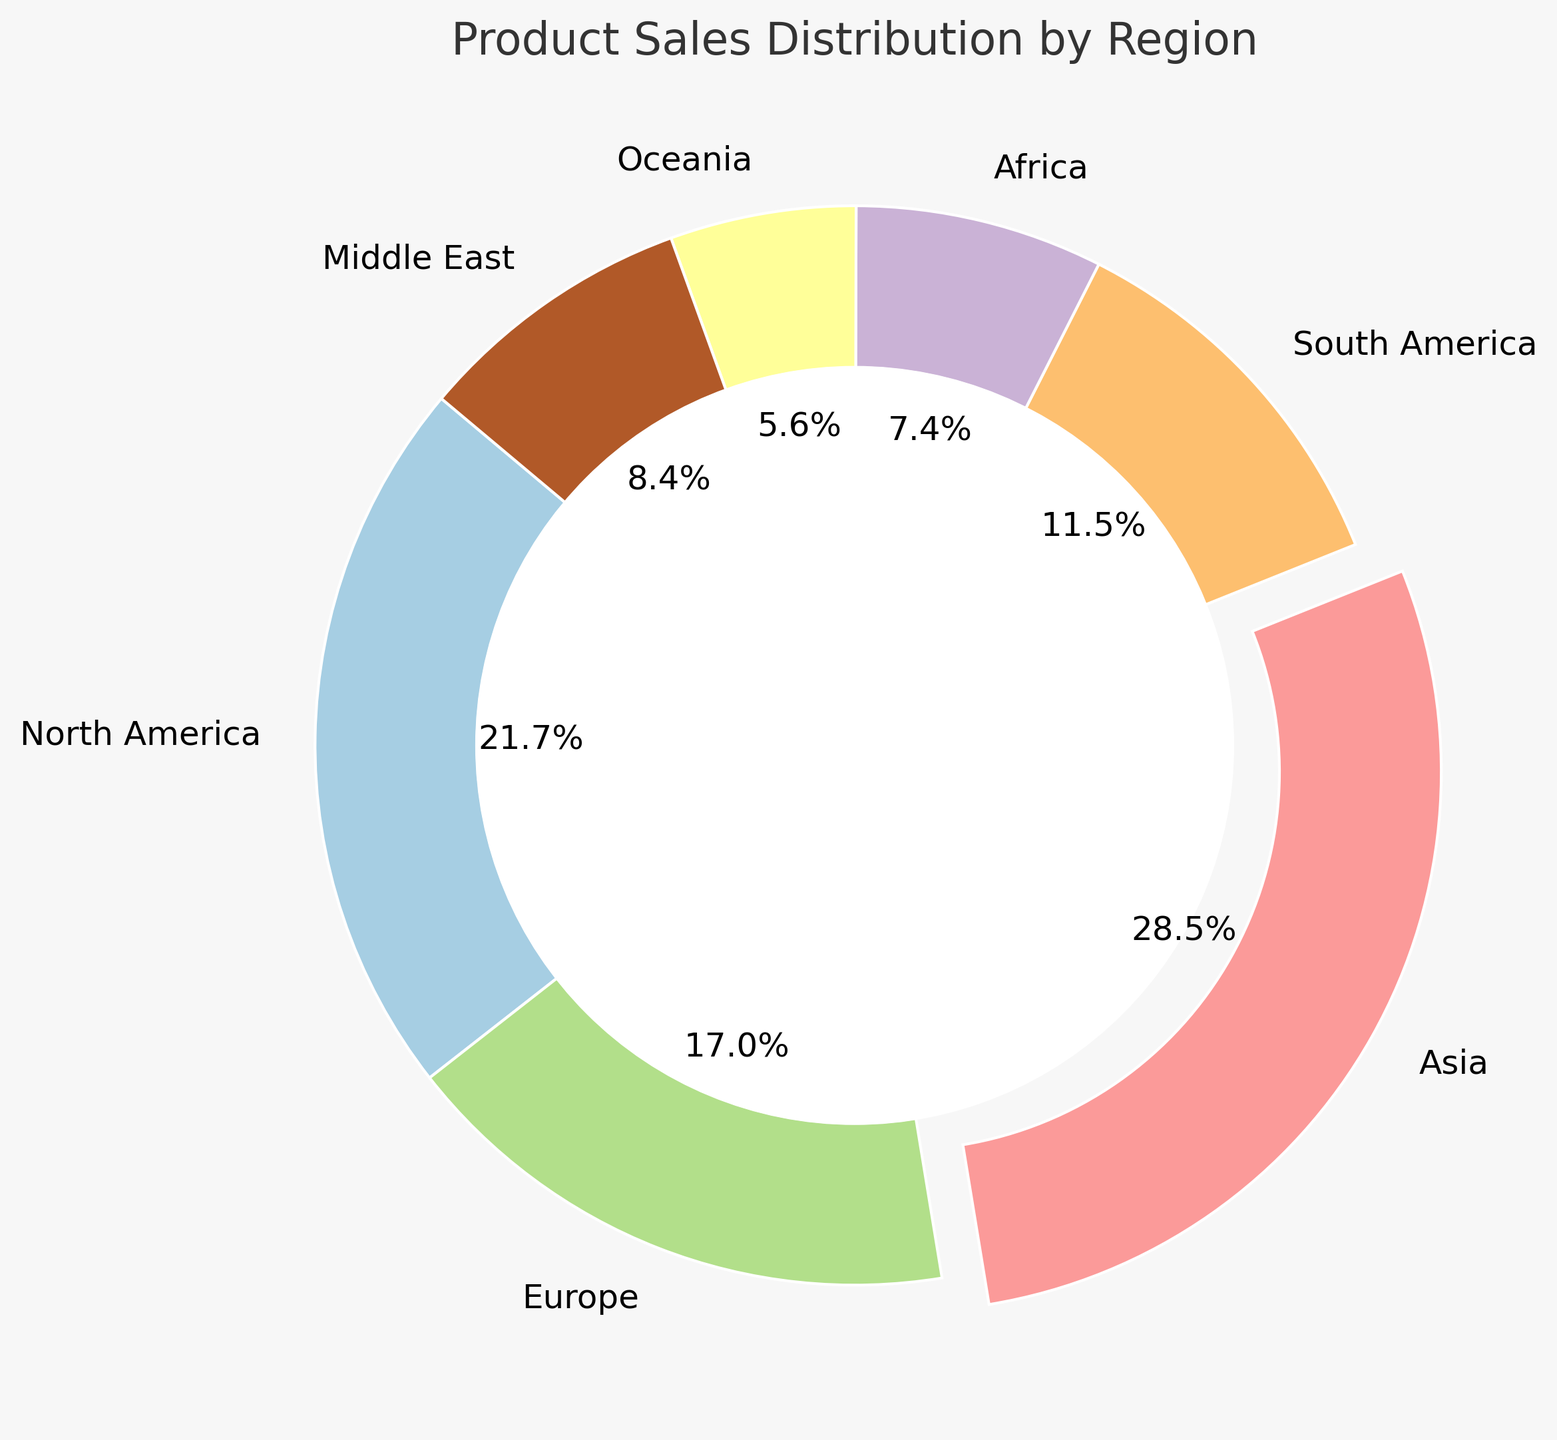Which region has the highest sales? By looking at the figure, the region with the largest segment and a noticeable separation (explode) is 'Asia'.
Answer: Asia Which region has the lowest sales? By examining the smallest segment in the chart, we can see that 'Oceania' has the lowest sales.
Answer: Oceania How do the sales in North America compare to those in Europe? By comparing the sizes of the segments, North America has a larger segment than Europe, indicating higher sales.
Answer: North America has higher sales What percentage of total sales comes from Asia and North America combined? Asia contributes 35.4% and North America contributes 26.9%. Adding these percentages gives 62.3%.
Answer: 62.3% Which regions together make up less than 20% of total sales? By examining the segments: Oceania (3.5%), Middle East (5.3%), and Africa (4.6%) sum up to 13.4%, which is less than 20%.
Answer: Oceania, Middle East, and Africa What is the average sales percentage for Europe, South America, and Middle East? Europe is 21.2%, South America is 14.3%, and Middle East is 10.4%. The average is (21.2 + 14.3 + 10.4) / 3 = 15.3%.
Answer: 15.3% How many regions have sales higher than 10%? By examining each segment: Asia (35.4%), North America (26.9%), Europe (21.2%), and South America (14.3%) have sales higher than 10%.
Answer: 4 regions What is the difference in sales percentage between the highest and lowest regions? The highest is Asia (35.4%) and the lowest is Oceania (3.5%). The difference is 35.4% - 3.5% = 31.9%.
Answer: 31.9% Which regions have sales percentages that are within 5% of each other? Europe (21.2%) and North America (26.9%) have a difference of 5.7%, while Europe and South America (14.3%) have a difference of 6.9%, and South America and Middle East (10.4%) have a difference of 3.9%. So, the closest are South America and Middle East.
Answer: South America and Middle East What fraction of total sales does Africa contribute? Africa accounts for 4.6% of total sales. Converting this percentage to a fraction: 4.6/100 = 23/500 or approximately 1/22 (simplified).
Answer: 1/22 